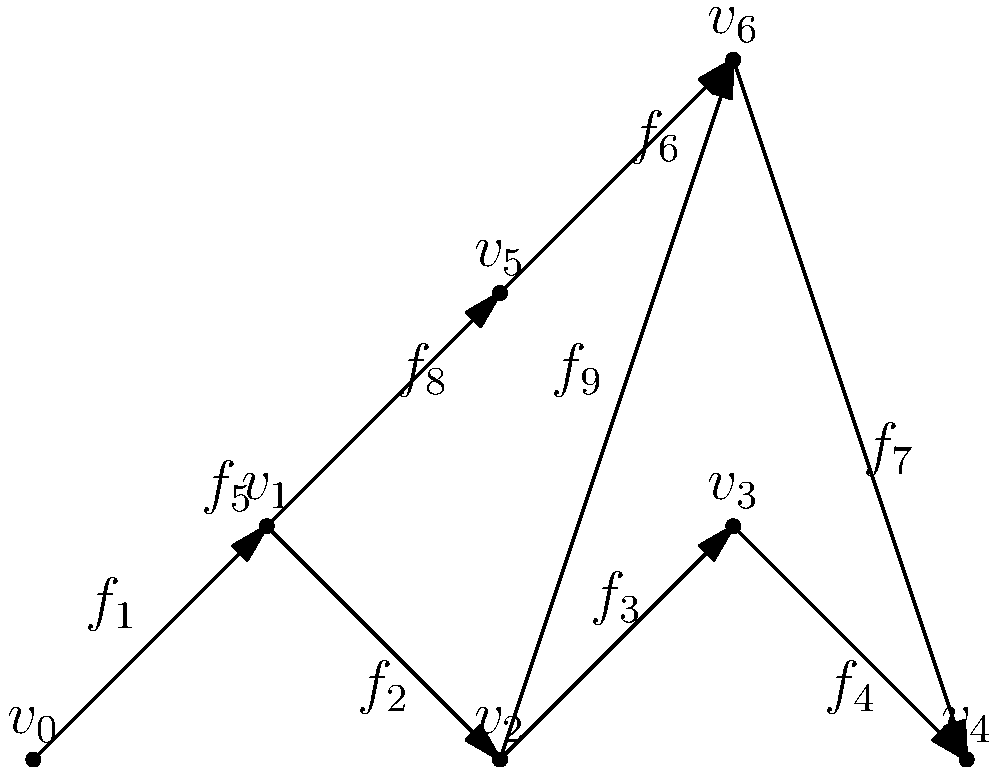The directed acyclic graph (DAG) above represents the distribution of forces on a ship's structure during a severe storm. Each vertex ($v_i$) represents a key structural point, and each edge ($f_j$) represents a force vector. What is the minimum number of force vectors that need to be analyzed to determine the total force experienced at vertex $v_4$? To determine the minimum number of force vectors needed to analyze the total force at $v_4$, we need to identify all paths leading to $v_4$ in the DAG. Here's the step-by-step process:

1. Identify all paths leading to $v_4$:
   Path 1: $v_0 \rightarrow v_1 \rightarrow v_2 \rightarrow v_3 \rightarrow v_4$
   Path 2: $v_0 \rightarrow v_5 \rightarrow v_6 \rightarrow v_4$

2. List the force vectors in each path:
   Path 1: $f_1, f_2, f_3, f_4$
   Path 2: $f_5, f_6, f_7$

3. Combine the force vectors from both paths:
   $\{f_1, f_2, f_3, f_4, f_5, f_6, f_7\}$

4. Count the unique force vectors:
   There are 7 unique force vectors in the combined set.

5. Note that $f_8$ and $f_9$ are not necessary for calculating the total force at $v_4$ as they do not contribute to any path leading to $v_4$.

Therefore, the minimum number of force vectors that need to be analyzed to determine the total force experienced at vertex $v_4$ is 7.
Answer: 7 